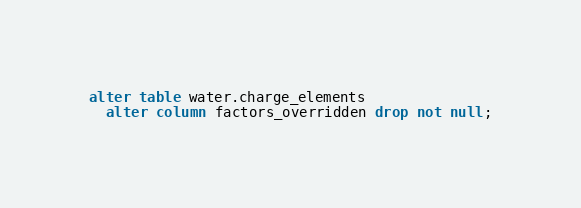Convert code to text. <code><loc_0><loc_0><loc_500><loc_500><_SQL_>alter table water.charge_elements 
  alter column factors_overridden drop not null;</code> 